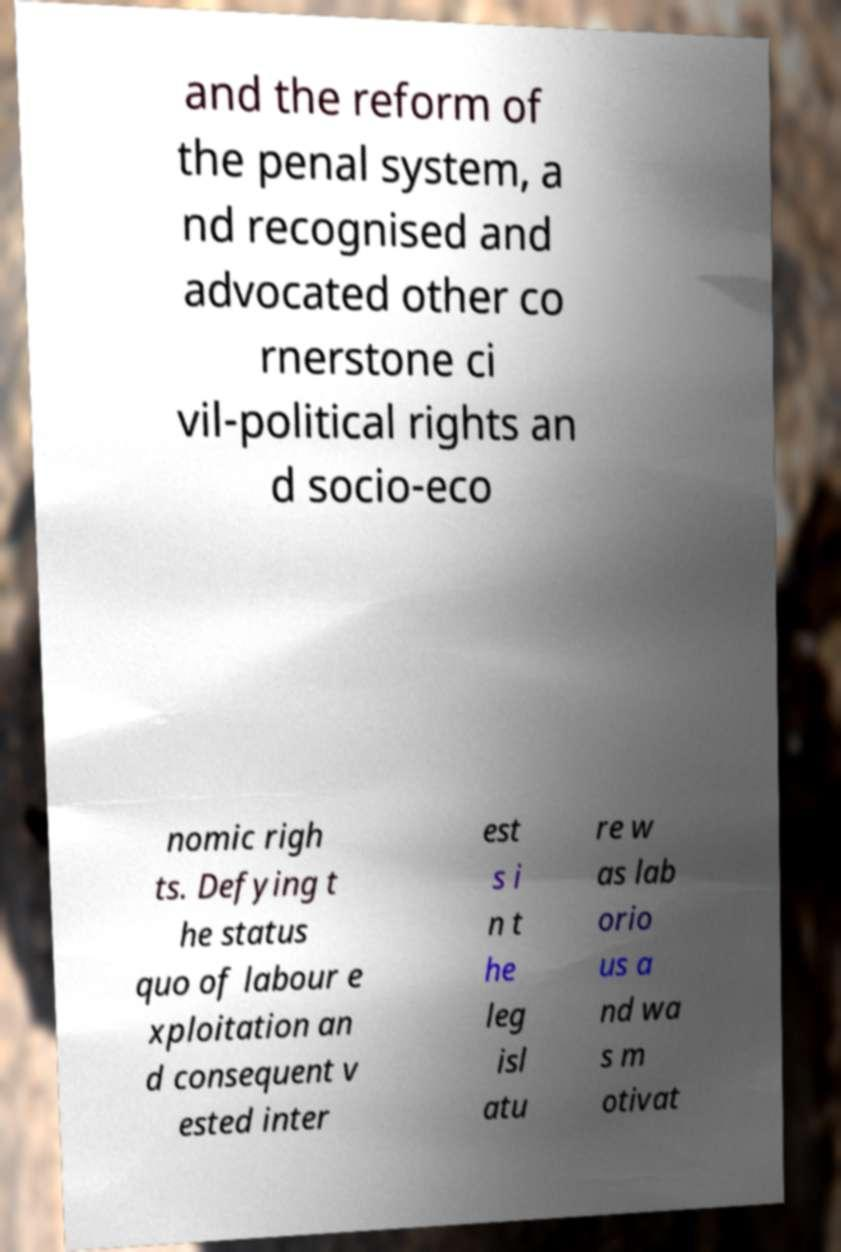Can you accurately transcribe the text from the provided image for me? and the reform of the penal system, a nd recognised and advocated other co rnerstone ci vil-political rights an d socio-eco nomic righ ts. Defying t he status quo of labour e xploitation an d consequent v ested inter est s i n t he leg isl atu re w as lab orio us a nd wa s m otivat 